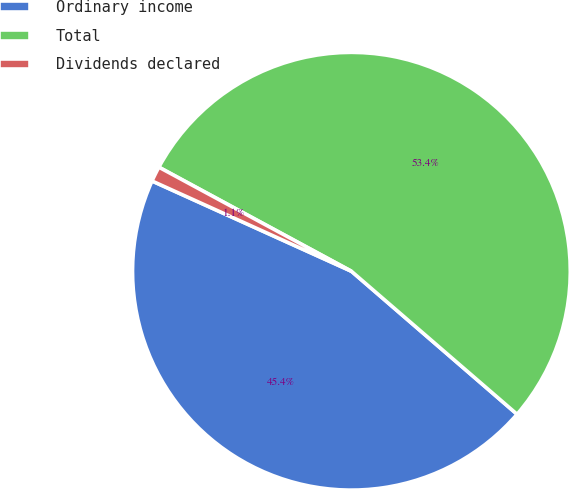<chart> <loc_0><loc_0><loc_500><loc_500><pie_chart><fcel>Ordinary income<fcel>Total<fcel>Dividends declared<nl><fcel>45.43%<fcel>53.45%<fcel>1.12%<nl></chart> 